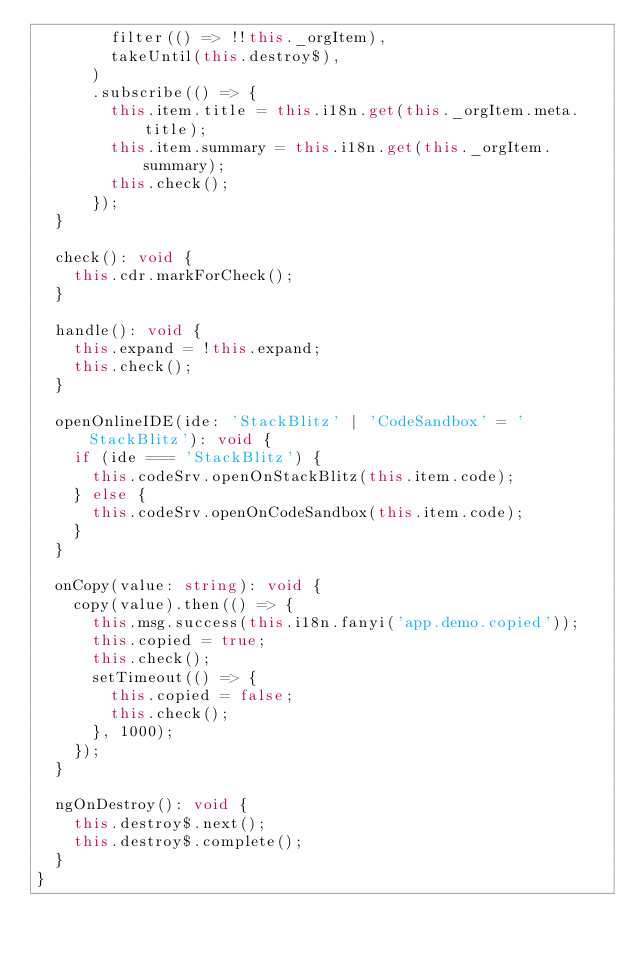<code> <loc_0><loc_0><loc_500><loc_500><_TypeScript_>        filter(() => !!this._orgItem),
        takeUntil(this.destroy$),
      )
      .subscribe(() => {
        this.item.title = this.i18n.get(this._orgItem.meta.title);
        this.item.summary = this.i18n.get(this._orgItem.summary);
        this.check();
      });
  }

  check(): void {
    this.cdr.markForCheck();
  }

  handle(): void {
    this.expand = !this.expand;
    this.check();
  }

  openOnlineIDE(ide: 'StackBlitz' | 'CodeSandbox' = 'StackBlitz'): void {
    if (ide === 'StackBlitz') {
      this.codeSrv.openOnStackBlitz(this.item.code);
    } else {
      this.codeSrv.openOnCodeSandbox(this.item.code);
    }
  }

  onCopy(value: string): void {
    copy(value).then(() => {
      this.msg.success(this.i18n.fanyi('app.demo.copied'));
      this.copied = true;
      this.check();
      setTimeout(() => {
        this.copied = false;
        this.check();
      }, 1000);
    });
  }

  ngOnDestroy(): void {
    this.destroy$.next();
    this.destroy$.complete();
  }
}
</code> 